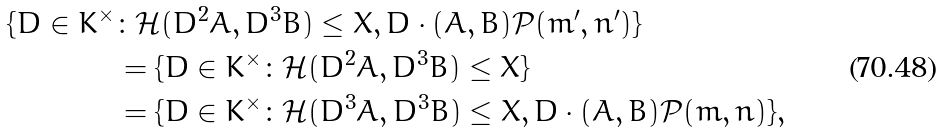<formula> <loc_0><loc_0><loc_500><loc_500>\{ D \in K ^ { \times } & \colon \mathcal { H } ( D ^ { 2 } A , D ^ { 3 } B ) \leq X , D \cdot ( A , B ) \mathcal { P } ( m ^ { \prime } , n ^ { \prime } ) \} \\ & = \{ D \in K ^ { \times } \colon \mathcal { H } ( D ^ { 2 } A , D ^ { 3 } B ) \leq X \} \\ & = \{ D \in K ^ { \times } \colon \mathcal { H } ( D ^ { 3 } A , D ^ { 3 } B ) \leq X , D \cdot ( A , B ) \mathcal { P } ( m , n ) \} ,</formula> 